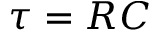Convert formula to latex. <formula><loc_0><loc_0><loc_500><loc_500>\tau = R C</formula> 